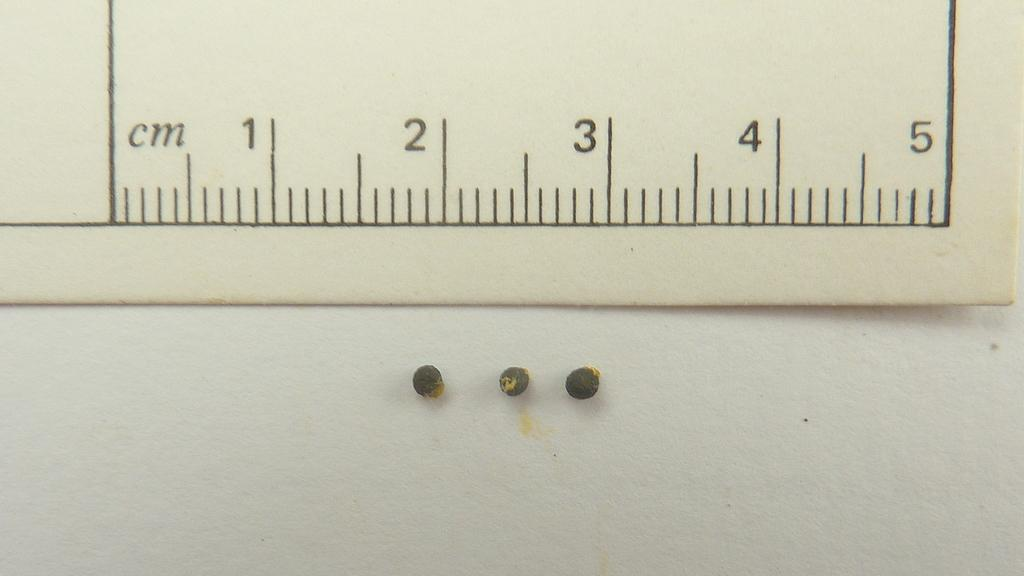Provide a one-sentence caption for the provided image. a ruler with cm measurements and three small buttons below it. 